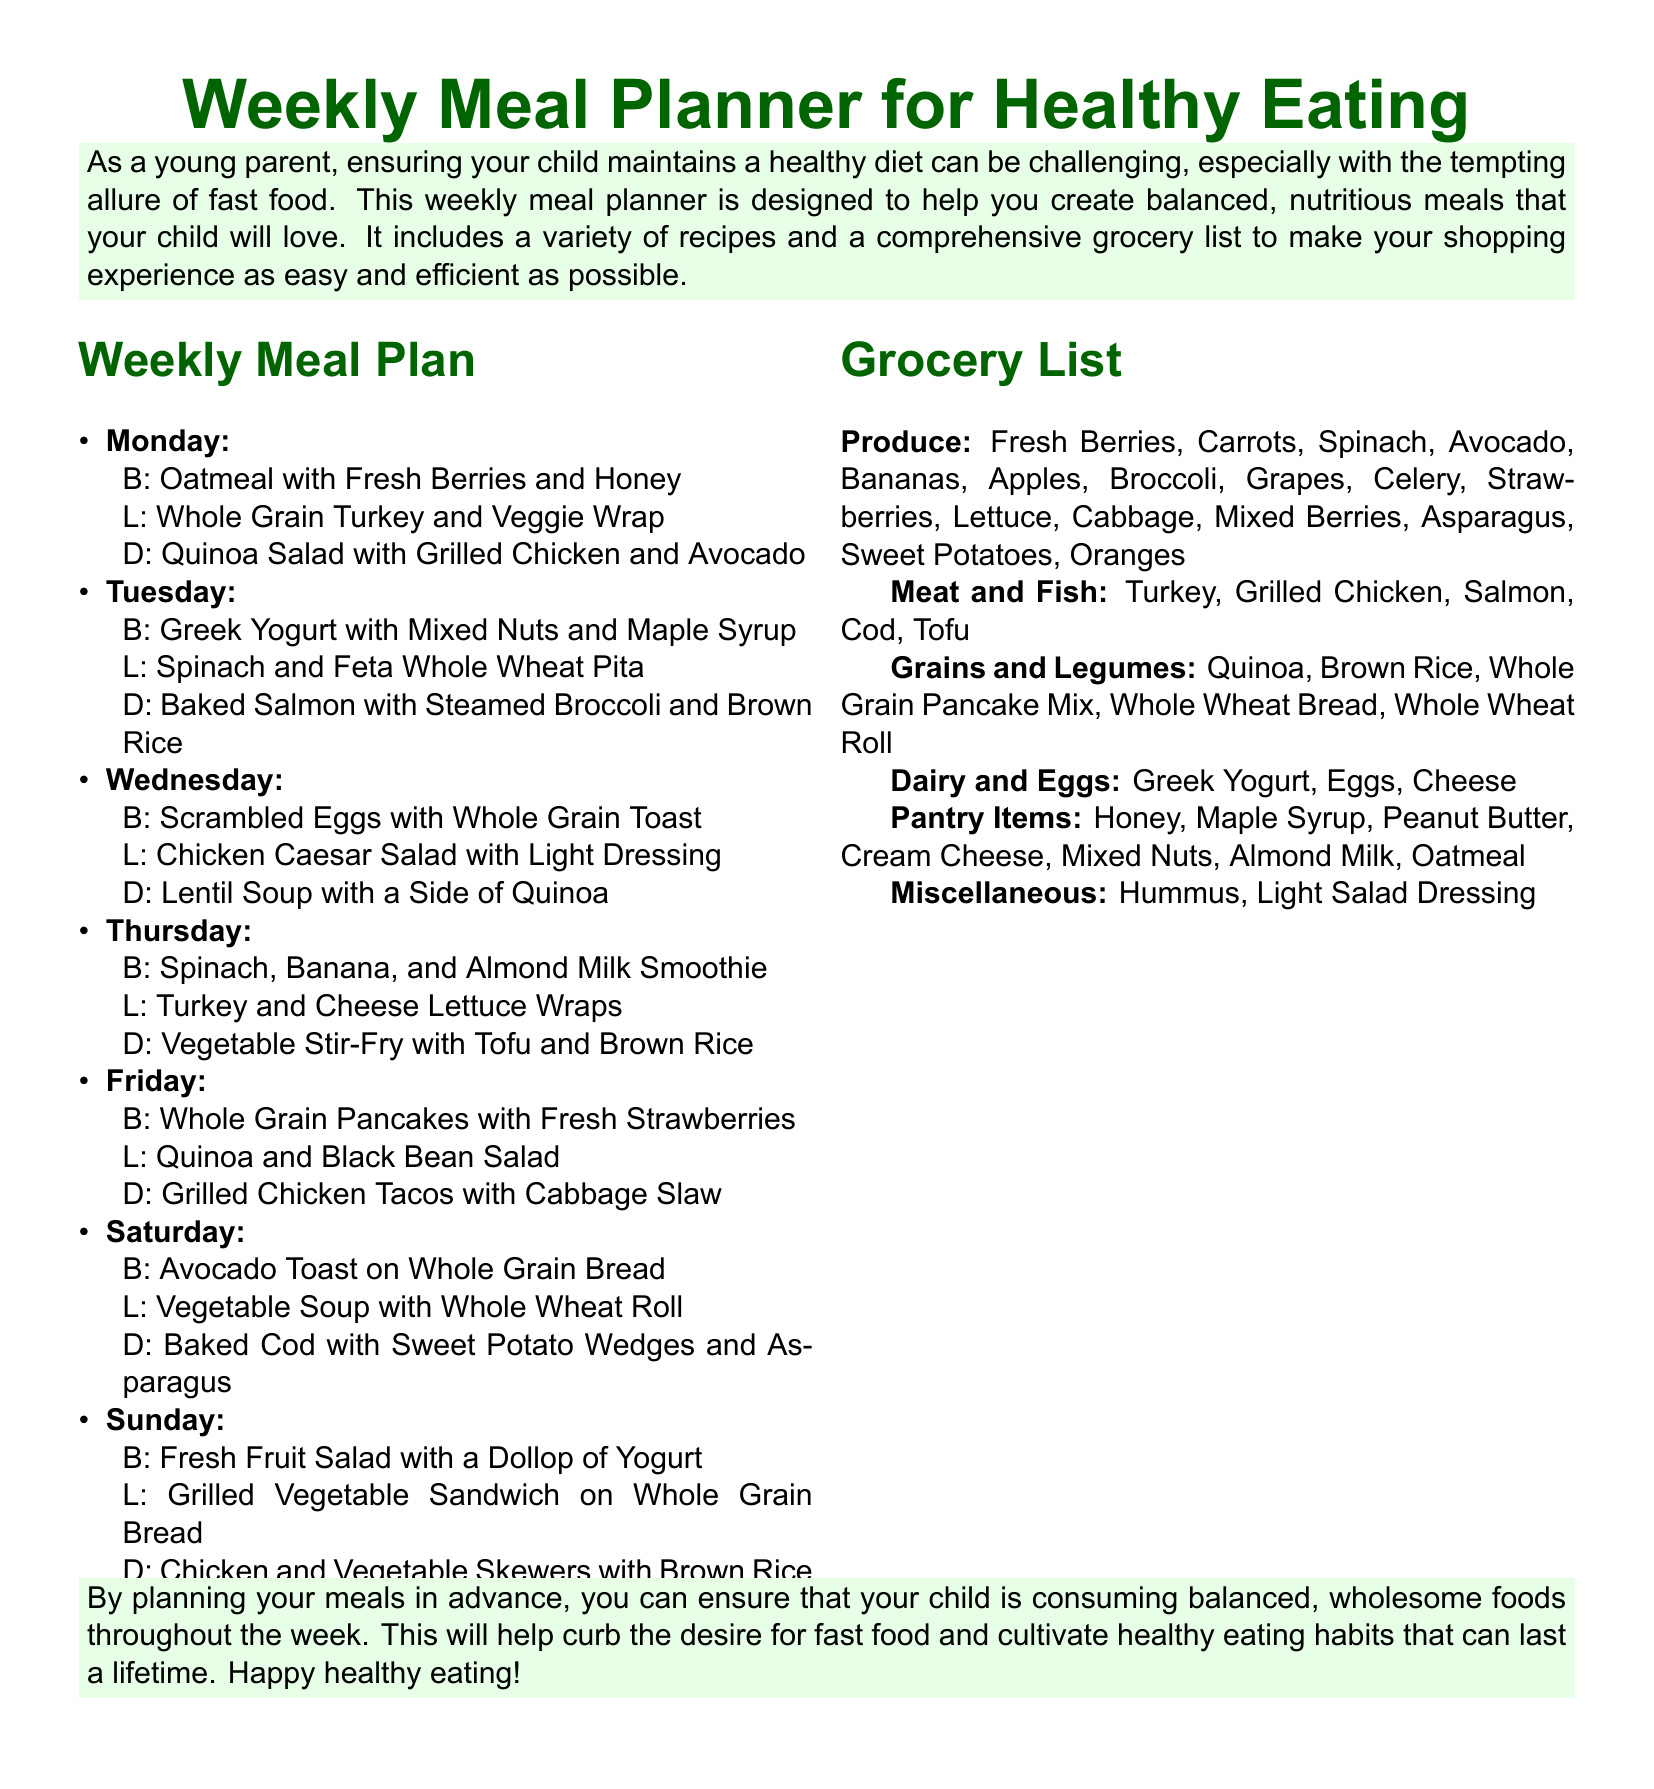What is the first meal on Monday? The first meal listed for Monday is Oatmeal with Fresh Berries and Honey.
Answer: Oatmeal with Fresh Berries and Honey What is the main ingredient in Tuesday's dinner? Tuesday's dinner is Baked Salmon with Steamed Broccoli and Brown Rice, indicating the main ingredient is salmon.
Answer: Salmon How many meals are planned for Saturday? Saturday has three meals listed: Breakfast, Lunch, and Dinner, totaling three meals.
Answer: Three meals What is the grocery list category that includes Tofu? Tofu is listed under the Meat and Fish category in the grocery list.
Answer: Meat and Fish What are the grains included in the grocery list? The grains are Quinoa, Brown Rice, Whole Grain Pancake Mix, Whole Wheat Bread, and Whole Wheat Roll.
Answer: Quinoa, Brown Rice, Whole Grain Pancake Mix, Whole Wheat Bread, Whole Wheat Roll Which day features a smoothie for breakfast? Thursday features a Spinach, Banana, and Almond Milk Smoothie for breakfast.
Answer: Thursday What type of dressing is suggested for the Wednesday lunch? The lunch on Wednesday is Chicken Caesar Salad with Light Dressing, indicating the dressing type.
Answer: Light Dressing How many different types of fruits are listed in the grocery list? The grocery list mentions Fresh Berries, Avocado, Bananas, Apples, Strawberries, Grapes, Oranges, and Mixed Berries, totaling eight different types of fruits.
Answer: Eight types of fruits 